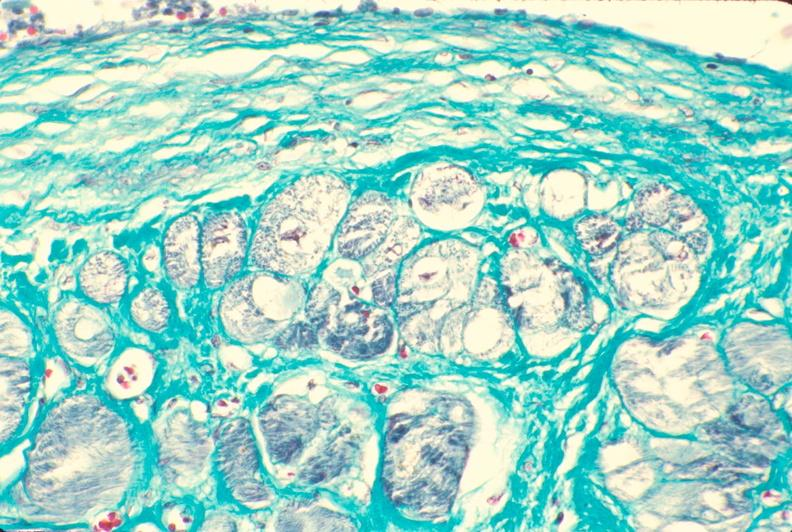what does this image show?
Answer the question using a single word or phrase. Heart 